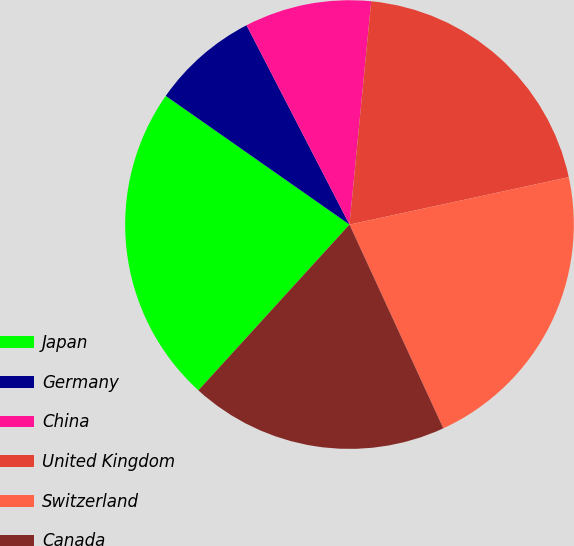<chart> <loc_0><loc_0><loc_500><loc_500><pie_chart><fcel>Japan<fcel>Germany<fcel>China<fcel>United Kingdom<fcel>Switzerland<fcel>Canada<nl><fcel>22.96%<fcel>7.69%<fcel>9.13%<fcel>20.07%<fcel>21.52%<fcel>18.63%<nl></chart> 